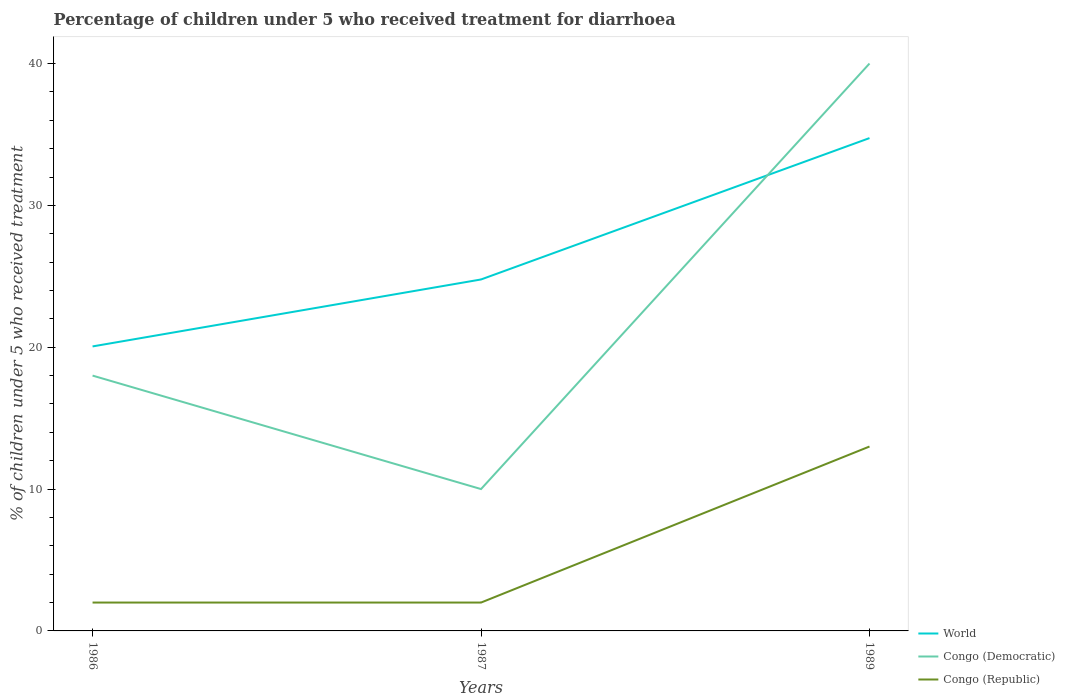How many different coloured lines are there?
Your answer should be very brief. 3. In which year was the percentage of children who received treatment for diarrhoea  in World maximum?
Ensure brevity in your answer.  1986. What is the total percentage of children who received treatment for diarrhoea  in World in the graph?
Ensure brevity in your answer.  -9.97. What is the difference between the highest and the lowest percentage of children who received treatment for diarrhoea  in Congo (Democratic)?
Your answer should be very brief. 1. What is the difference between two consecutive major ticks on the Y-axis?
Provide a succinct answer. 10. Are the values on the major ticks of Y-axis written in scientific E-notation?
Your answer should be very brief. No. Does the graph contain any zero values?
Your response must be concise. No. Where does the legend appear in the graph?
Your answer should be very brief. Bottom right. How are the legend labels stacked?
Offer a terse response. Vertical. What is the title of the graph?
Provide a short and direct response. Percentage of children under 5 who received treatment for diarrhoea. What is the label or title of the Y-axis?
Your response must be concise. % of children under 5 who received treatment. What is the % of children under 5 who received treatment in World in 1986?
Provide a short and direct response. 20.06. What is the % of children under 5 who received treatment of Congo (Democratic) in 1986?
Keep it short and to the point. 18. What is the % of children under 5 who received treatment in World in 1987?
Give a very brief answer. 24.78. What is the % of children under 5 who received treatment of Congo (Democratic) in 1987?
Offer a terse response. 10. What is the % of children under 5 who received treatment of World in 1989?
Ensure brevity in your answer.  34.74. What is the % of children under 5 who received treatment in Congo (Democratic) in 1989?
Offer a very short reply. 40. Across all years, what is the maximum % of children under 5 who received treatment in World?
Provide a short and direct response. 34.74. Across all years, what is the maximum % of children under 5 who received treatment of Congo (Republic)?
Ensure brevity in your answer.  13. Across all years, what is the minimum % of children under 5 who received treatment of World?
Provide a short and direct response. 20.06. Across all years, what is the minimum % of children under 5 who received treatment in Congo (Democratic)?
Offer a very short reply. 10. What is the total % of children under 5 who received treatment of World in the graph?
Offer a terse response. 79.58. What is the total % of children under 5 who received treatment of Congo (Democratic) in the graph?
Your answer should be very brief. 68. What is the total % of children under 5 who received treatment of Congo (Republic) in the graph?
Ensure brevity in your answer.  17. What is the difference between the % of children under 5 who received treatment of World in 1986 and that in 1987?
Your answer should be compact. -4.72. What is the difference between the % of children under 5 who received treatment in World in 1986 and that in 1989?
Ensure brevity in your answer.  -14.69. What is the difference between the % of children under 5 who received treatment in World in 1987 and that in 1989?
Provide a succinct answer. -9.97. What is the difference between the % of children under 5 who received treatment in World in 1986 and the % of children under 5 who received treatment in Congo (Democratic) in 1987?
Your answer should be very brief. 10.06. What is the difference between the % of children under 5 who received treatment of World in 1986 and the % of children under 5 who received treatment of Congo (Republic) in 1987?
Offer a very short reply. 18.06. What is the difference between the % of children under 5 who received treatment of World in 1986 and the % of children under 5 who received treatment of Congo (Democratic) in 1989?
Make the answer very short. -19.94. What is the difference between the % of children under 5 who received treatment in World in 1986 and the % of children under 5 who received treatment in Congo (Republic) in 1989?
Provide a short and direct response. 7.06. What is the difference between the % of children under 5 who received treatment in World in 1987 and the % of children under 5 who received treatment in Congo (Democratic) in 1989?
Your answer should be compact. -15.22. What is the difference between the % of children under 5 who received treatment of World in 1987 and the % of children under 5 who received treatment of Congo (Republic) in 1989?
Make the answer very short. 11.78. What is the average % of children under 5 who received treatment in World per year?
Keep it short and to the point. 26.53. What is the average % of children under 5 who received treatment in Congo (Democratic) per year?
Offer a very short reply. 22.67. What is the average % of children under 5 who received treatment in Congo (Republic) per year?
Provide a succinct answer. 5.67. In the year 1986, what is the difference between the % of children under 5 who received treatment of World and % of children under 5 who received treatment of Congo (Democratic)?
Provide a succinct answer. 2.06. In the year 1986, what is the difference between the % of children under 5 who received treatment of World and % of children under 5 who received treatment of Congo (Republic)?
Make the answer very short. 18.06. In the year 1986, what is the difference between the % of children under 5 who received treatment in Congo (Democratic) and % of children under 5 who received treatment in Congo (Republic)?
Make the answer very short. 16. In the year 1987, what is the difference between the % of children under 5 who received treatment of World and % of children under 5 who received treatment of Congo (Democratic)?
Your answer should be very brief. 14.78. In the year 1987, what is the difference between the % of children under 5 who received treatment of World and % of children under 5 who received treatment of Congo (Republic)?
Offer a very short reply. 22.78. In the year 1989, what is the difference between the % of children under 5 who received treatment in World and % of children under 5 who received treatment in Congo (Democratic)?
Ensure brevity in your answer.  -5.26. In the year 1989, what is the difference between the % of children under 5 who received treatment of World and % of children under 5 who received treatment of Congo (Republic)?
Offer a very short reply. 21.74. What is the ratio of the % of children under 5 who received treatment of World in 1986 to that in 1987?
Give a very brief answer. 0.81. What is the ratio of the % of children under 5 who received treatment in World in 1986 to that in 1989?
Your answer should be very brief. 0.58. What is the ratio of the % of children under 5 who received treatment in Congo (Democratic) in 1986 to that in 1989?
Your answer should be very brief. 0.45. What is the ratio of the % of children under 5 who received treatment of Congo (Republic) in 1986 to that in 1989?
Your answer should be very brief. 0.15. What is the ratio of the % of children under 5 who received treatment in World in 1987 to that in 1989?
Your answer should be compact. 0.71. What is the ratio of the % of children under 5 who received treatment in Congo (Republic) in 1987 to that in 1989?
Your response must be concise. 0.15. What is the difference between the highest and the second highest % of children under 5 who received treatment in World?
Your answer should be very brief. 9.97. What is the difference between the highest and the second highest % of children under 5 who received treatment in Congo (Democratic)?
Give a very brief answer. 22. What is the difference between the highest and the second highest % of children under 5 who received treatment in Congo (Republic)?
Provide a short and direct response. 11. What is the difference between the highest and the lowest % of children under 5 who received treatment in World?
Provide a succinct answer. 14.69. What is the difference between the highest and the lowest % of children under 5 who received treatment of Congo (Democratic)?
Offer a terse response. 30. 